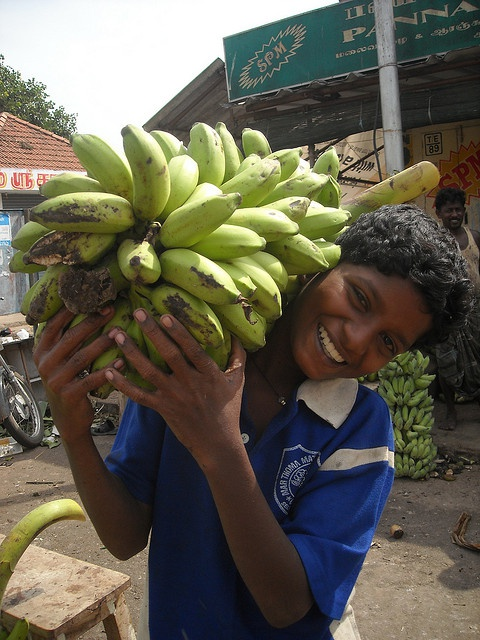Describe the objects in this image and their specific colors. I can see people in lightgray, black, maroon, navy, and gray tones, banana in lightgray, olive, black, and khaki tones, bench in lightgray, tan, and olive tones, motorcycle in lightgray, gray, black, and darkgray tones, and banana in lightgray and olive tones in this image. 